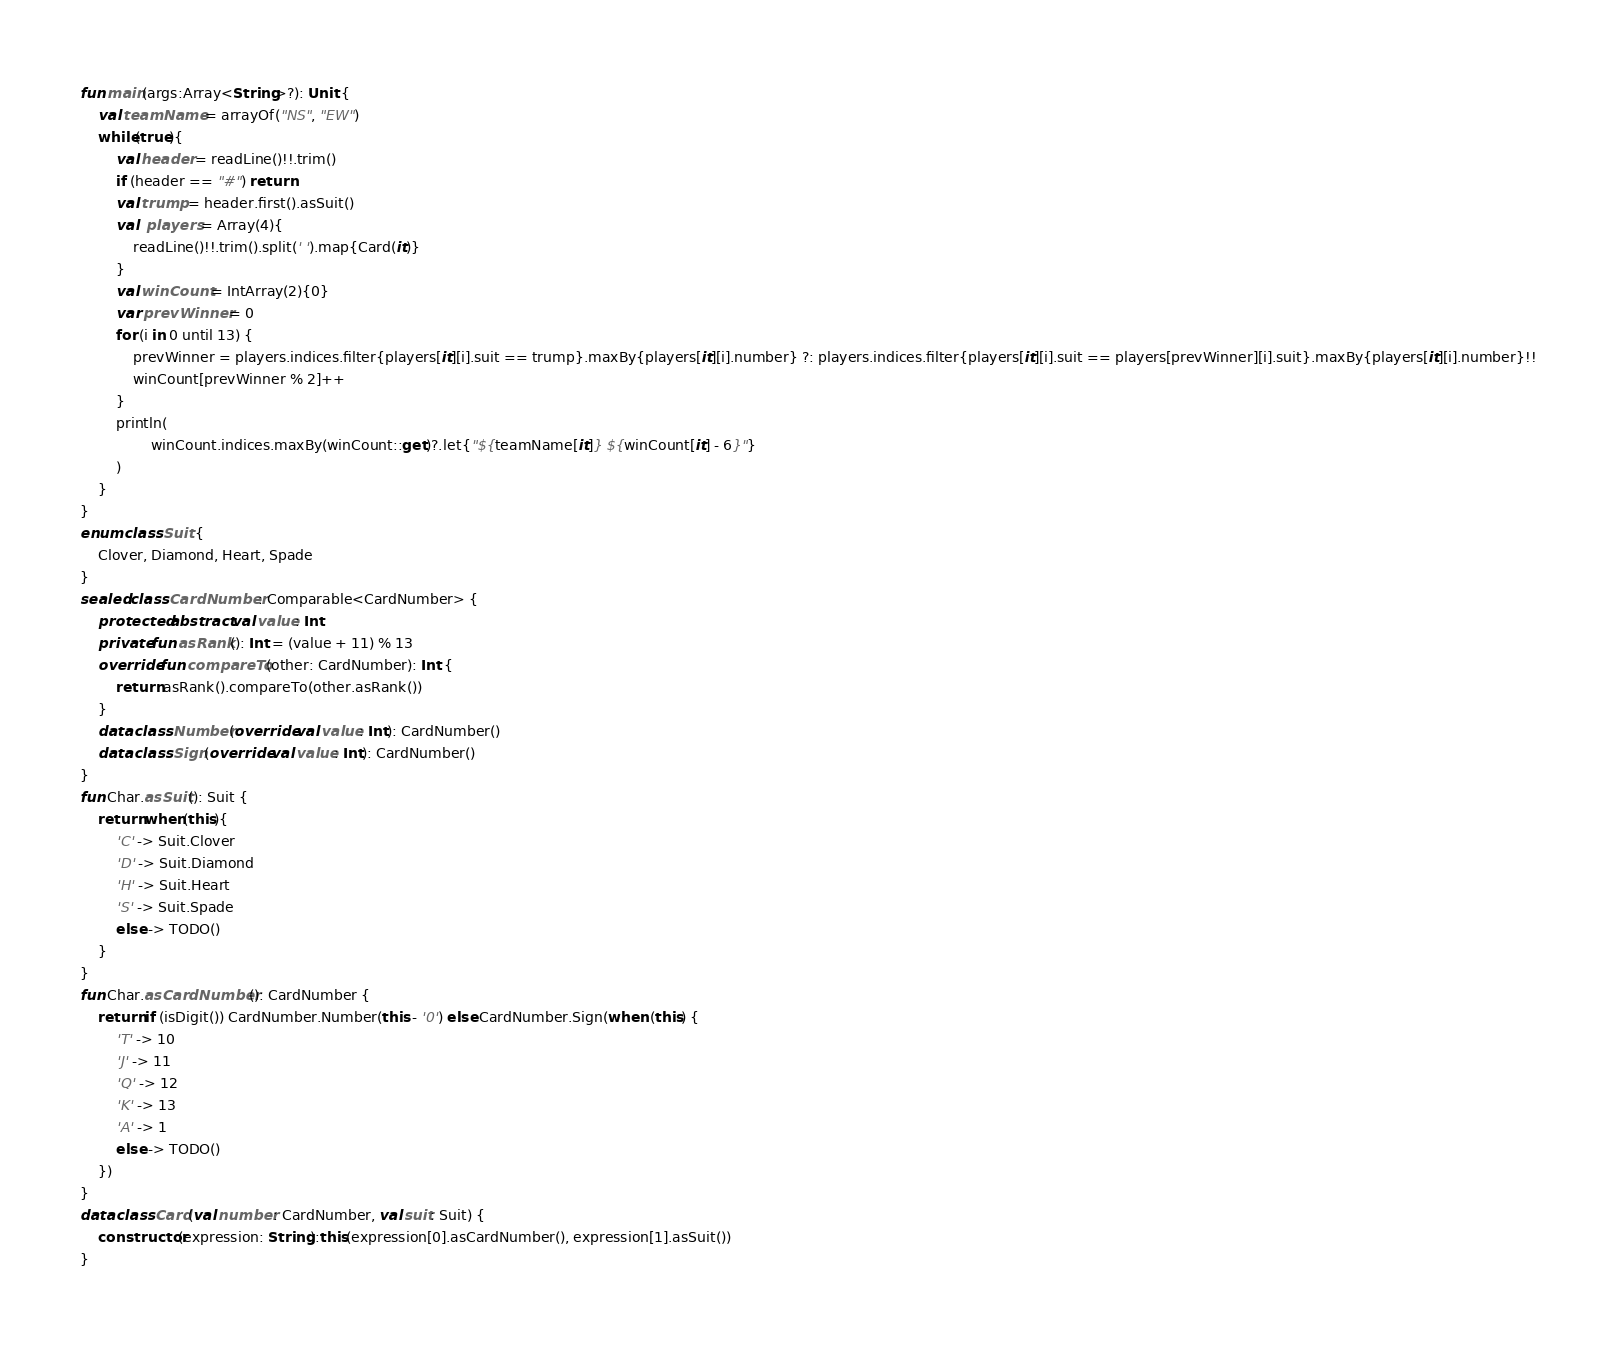Convert code to text. <code><loc_0><loc_0><loc_500><loc_500><_Kotlin_>fun main(args:Array<String>?): Unit {
    val teamName = arrayOf("NS", "EW")
    while(true){
        val header = readLine()!!.trim()
        if (header == "#") return
        val trump = header.first().asSuit()
        val  players = Array(4){
            readLine()!!.trim().split(' ').map{Card(it)}
        }
        val winCount = IntArray(2){0}
        var prevWinner = 0
        for (i in 0 until 13) {
            prevWinner = players.indices.filter{players[it][i].suit == trump}.maxBy{players[it][i].number} ?: players.indices.filter{players[it][i].suit == players[prevWinner][i].suit}.maxBy{players[it][i].number}!!
            winCount[prevWinner % 2]++
        }
        println(
                winCount.indices.maxBy(winCount::get)?.let{"${teamName[it]} ${winCount[it] - 6}"}
        )
    }
}
enum class Suit {
    Clover, Diamond, Heart, Spade
}
sealed class CardNumber: Comparable<CardNumber> {
    protected abstract val value: Int
    private fun asRank(): Int = (value + 11) % 13
    override fun compareTo(other: CardNumber): Int {
        return asRank().compareTo(other.asRank())
    }
    data class Number(override val value: Int): CardNumber()
    data class Sign(override val value: Int): CardNumber()
}
fun Char.asSuit(): Suit {
    return when(this){
        'C' -> Suit.Clover
        'D' -> Suit.Diamond
        'H' -> Suit.Heart
        'S' -> Suit.Spade
        else -> TODO()
    }
}
fun Char.asCardNumber(): CardNumber {
    return if (isDigit()) CardNumber.Number(this - '0') else CardNumber.Sign(when (this) {
        'T' -> 10
        'J' -> 11
        'Q' -> 12
        'K' -> 13
        'A' -> 1
        else -> TODO()
    })
}
data class Card(val number: CardNumber, val suit: Suit) {
    constructor(expression: String):this(expression[0].asCardNumber(), expression[1].asSuit())
}
</code> 